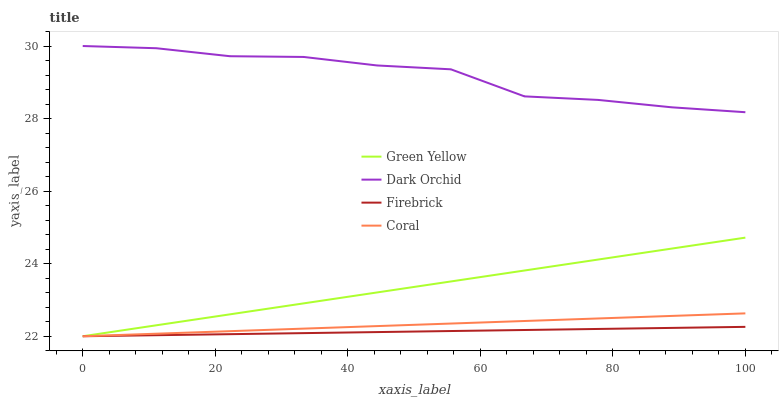Does Firebrick have the minimum area under the curve?
Answer yes or no. Yes. Does Dark Orchid have the maximum area under the curve?
Answer yes or no. Yes. Does Green Yellow have the minimum area under the curve?
Answer yes or no. No. Does Green Yellow have the maximum area under the curve?
Answer yes or no. No. Is Firebrick the smoothest?
Answer yes or no. Yes. Is Dark Orchid the roughest?
Answer yes or no. Yes. Is Green Yellow the smoothest?
Answer yes or no. No. Is Green Yellow the roughest?
Answer yes or no. No. Does Firebrick have the lowest value?
Answer yes or no. Yes. Does Dark Orchid have the lowest value?
Answer yes or no. No. Does Dark Orchid have the highest value?
Answer yes or no. Yes. Does Green Yellow have the highest value?
Answer yes or no. No. Is Coral less than Dark Orchid?
Answer yes or no. Yes. Is Dark Orchid greater than Green Yellow?
Answer yes or no. Yes. Does Coral intersect Firebrick?
Answer yes or no. Yes. Is Coral less than Firebrick?
Answer yes or no. No. Is Coral greater than Firebrick?
Answer yes or no. No. Does Coral intersect Dark Orchid?
Answer yes or no. No. 